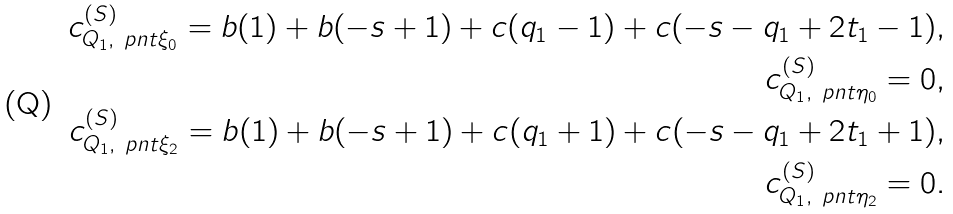<formula> <loc_0><loc_0><loc_500><loc_500>c _ { Q _ { 1 } , \ p n t { \xi _ { 0 } } } ^ { ( S ) } = b ( 1 ) + b ( - s + 1 ) + c ( q _ { 1 } - 1 ) + c ( - s - q _ { 1 } + 2 t _ { 1 } - 1 ) , \\ c _ { Q _ { 1 } , \ p n t { \eta _ { 0 } } } ^ { ( S ) } = 0 , \\ c _ { Q _ { 1 } , \ p n t { \xi _ { 2 } } } ^ { ( S ) } = b ( 1 ) + b ( - s + 1 ) + c ( q _ { 1 } + 1 ) + c ( - s - q _ { 1 } + 2 t _ { 1 } + 1 ) , \\ c _ { Q _ { 1 } , \ p n t { \eta _ { 2 } } } ^ { ( S ) } = 0 .</formula> 